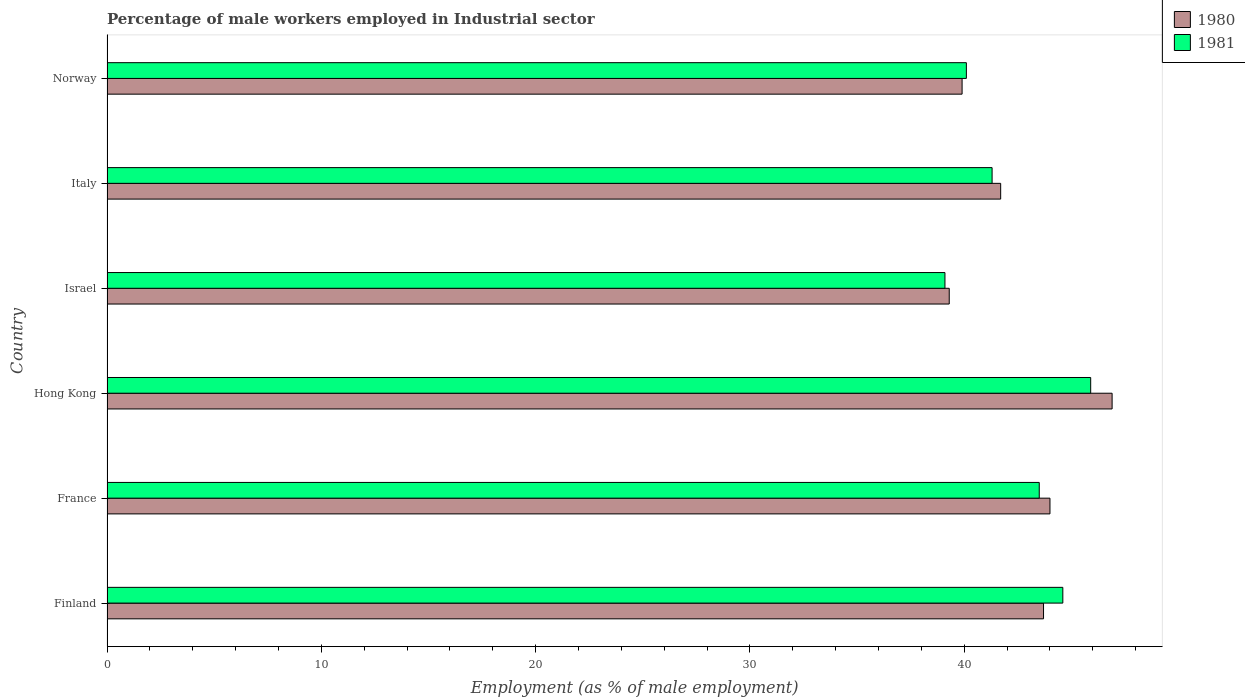How many groups of bars are there?
Keep it short and to the point. 6. Are the number of bars per tick equal to the number of legend labels?
Your answer should be compact. Yes. Are the number of bars on each tick of the Y-axis equal?
Keep it short and to the point. Yes. How many bars are there on the 1st tick from the top?
Provide a short and direct response. 2. How many bars are there on the 5th tick from the bottom?
Offer a terse response. 2. What is the label of the 4th group of bars from the top?
Keep it short and to the point. Hong Kong. What is the percentage of male workers employed in Industrial sector in 1980 in Hong Kong?
Your response must be concise. 46.9. Across all countries, what is the maximum percentage of male workers employed in Industrial sector in 1981?
Offer a terse response. 45.9. Across all countries, what is the minimum percentage of male workers employed in Industrial sector in 1980?
Offer a terse response. 39.3. In which country was the percentage of male workers employed in Industrial sector in 1980 maximum?
Offer a terse response. Hong Kong. What is the total percentage of male workers employed in Industrial sector in 1981 in the graph?
Provide a short and direct response. 254.5. What is the difference between the percentage of male workers employed in Industrial sector in 1980 in Finland and that in France?
Provide a short and direct response. -0.3. What is the difference between the percentage of male workers employed in Industrial sector in 1980 in Finland and the percentage of male workers employed in Industrial sector in 1981 in Norway?
Make the answer very short. 3.6. What is the average percentage of male workers employed in Industrial sector in 1980 per country?
Ensure brevity in your answer.  42.58. What is the difference between the percentage of male workers employed in Industrial sector in 1981 and percentage of male workers employed in Industrial sector in 1980 in Norway?
Provide a short and direct response. 0.2. What is the ratio of the percentage of male workers employed in Industrial sector in 1980 in Hong Kong to that in Norway?
Offer a very short reply. 1.18. What is the difference between the highest and the second highest percentage of male workers employed in Industrial sector in 1981?
Provide a short and direct response. 1.3. What is the difference between the highest and the lowest percentage of male workers employed in Industrial sector in 1980?
Ensure brevity in your answer.  7.6. In how many countries, is the percentage of male workers employed in Industrial sector in 1980 greater than the average percentage of male workers employed in Industrial sector in 1980 taken over all countries?
Provide a short and direct response. 3. Is the sum of the percentage of male workers employed in Industrial sector in 1981 in France and Hong Kong greater than the maximum percentage of male workers employed in Industrial sector in 1980 across all countries?
Make the answer very short. Yes. What does the 1st bar from the top in Norway represents?
Provide a short and direct response. 1981. How many bars are there?
Ensure brevity in your answer.  12. How many countries are there in the graph?
Make the answer very short. 6. Are the values on the major ticks of X-axis written in scientific E-notation?
Give a very brief answer. No. Does the graph contain any zero values?
Provide a short and direct response. No. Where does the legend appear in the graph?
Give a very brief answer. Top right. What is the title of the graph?
Offer a terse response. Percentage of male workers employed in Industrial sector. What is the label or title of the X-axis?
Your response must be concise. Employment (as % of male employment). What is the Employment (as % of male employment) in 1980 in Finland?
Offer a terse response. 43.7. What is the Employment (as % of male employment) in 1981 in Finland?
Offer a terse response. 44.6. What is the Employment (as % of male employment) of 1981 in France?
Ensure brevity in your answer.  43.5. What is the Employment (as % of male employment) in 1980 in Hong Kong?
Offer a very short reply. 46.9. What is the Employment (as % of male employment) of 1981 in Hong Kong?
Make the answer very short. 45.9. What is the Employment (as % of male employment) of 1980 in Israel?
Keep it short and to the point. 39.3. What is the Employment (as % of male employment) in 1981 in Israel?
Provide a succinct answer. 39.1. What is the Employment (as % of male employment) in 1980 in Italy?
Ensure brevity in your answer.  41.7. What is the Employment (as % of male employment) in 1981 in Italy?
Keep it short and to the point. 41.3. What is the Employment (as % of male employment) in 1980 in Norway?
Your answer should be compact. 39.9. What is the Employment (as % of male employment) in 1981 in Norway?
Make the answer very short. 40.1. Across all countries, what is the maximum Employment (as % of male employment) in 1980?
Keep it short and to the point. 46.9. Across all countries, what is the maximum Employment (as % of male employment) in 1981?
Offer a very short reply. 45.9. Across all countries, what is the minimum Employment (as % of male employment) in 1980?
Ensure brevity in your answer.  39.3. Across all countries, what is the minimum Employment (as % of male employment) in 1981?
Your response must be concise. 39.1. What is the total Employment (as % of male employment) of 1980 in the graph?
Your response must be concise. 255.5. What is the total Employment (as % of male employment) in 1981 in the graph?
Keep it short and to the point. 254.5. What is the difference between the Employment (as % of male employment) in 1980 in Finland and that in France?
Keep it short and to the point. -0.3. What is the difference between the Employment (as % of male employment) of 1981 in Finland and that in France?
Keep it short and to the point. 1.1. What is the difference between the Employment (as % of male employment) in 1980 in Finland and that in Hong Kong?
Make the answer very short. -3.2. What is the difference between the Employment (as % of male employment) of 1980 in Finland and that in Norway?
Your response must be concise. 3.8. What is the difference between the Employment (as % of male employment) in 1981 in France and that in Hong Kong?
Provide a short and direct response. -2.4. What is the difference between the Employment (as % of male employment) of 1981 in France and that in Israel?
Your response must be concise. 4.4. What is the difference between the Employment (as % of male employment) of 1980 in France and that in Norway?
Make the answer very short. 4.1. What is the difference between the Employment (as % of male employment) of 1981 in France and that in Norway?
Give a very brief answer. 3.4. What is the difference between the Employment (as % of male employment) in 1980 in Hong Kong and that in Israel?
Make the answer very short. 7.6. What is the difference between the Employment (as % of male employment) of 1981 in Hong Kong and that in Israel?
Your answer should be very brief. 6.8. What is the difference between the Employment (as % of male employment) in 1981 in Hong Kong and that in Italy?
Keep it short and to the point. 4.6. What is the difference between the Employment (as % of male employment) in 1980 in Israel and that in Italy?
Offer a very short reply. -2.4. What is the difference between the Employment (as % of male employment) of 1981 in Israel and that in Italy?
Offer a very short reply. -2.2. What is the difference between the Employment (as % of male employment) of 1981 in Israel and that in Norway?
Make the answer very short. -1. What is the difference between the Employment (as % of male employment) of 1980 in Italy and that in Norway?
Provide a succinct answer. 1.8. What is the difference between the Employment (as % of male employment) in 1980 in Finland and the Employment (as % of male employment) in 1981 in France?
Provide a succinct answer. 0.2. What is the difference between the Employment (as % of male employment) of 1980 in Finland and the Employment (as % of male employment) of 1981 in Hong Kong?
Make the answer very short. -2.2. What is the difference between the Employment (as % of male employment) of 1980 in Finland and the Employment (as % of male employment) of 1981 in Israel?
Make the answer very short. 4.6. What is the difference between the Employment (as % of male employment) in 1980 in France and the Employment (as % of male employment) in 1981 in Hong Kong?
Make the answer very short. -1.9. What is the difference between the Employment (as % of male employment) of 1980 in France and the Employment (as % of male employment) of 1981 in Israel?
Make the answer very short. 4.9. What is the difference between the Employment (as % of male employment) in 1980 in France and the Employment (as % of male employment) in 1981 in Italy?
Offer a very short reply. 2.7. What is the difference between the Employment (as % of male employment) of 1980 in Hong Kong and the Employment (as % of male employment) of 1981 in Israel?
Your response must be concise. 7.8. What is the difference between the Employment (as % of male employment) in 1980 in Hong Kong and the Employment (as % of male employment) in 1981 in Italy?
Offer a terse response. 5.6. What is the difference between the Employment (as % of male employment) in 1980 in Hong Kong and the Employment (as % of male employment) in 1981 in Norway?
Keep it short and to the point. 6.8. What is the average Employment (as % of male employment) of 1980 per country?
Offer a very short reply. 42.58. What is the average Employment (as % of male employment) of 1981 per country?
Provide a succinct answer. 42.42. What is the difference between the Employment (as % of male employment) in 1980 and Employment (as % of male employment) in 1981 in Finland?
Provide a short and direct response. -0.9. What is the difference between the Employment (as % of male employment) of 1980 and Employment (as % of male employment) of 1981 in Israel?
Make the answer very short. 0.2. What is the ratio of the Employment (as % of male employment) in 1981 in Finland to that in France?
Your answer should be compact. 1.03. What is the ratio of the Employment (as % of male employment) of 1980 in Finland to that in Hong Kong?
Your answer should be compact. 0.93. What is the ratio of the Employment (as % of male employment) in 1981 in Finland to that in Hong Kong?
Offer a very short reply. 0.97. What is the ratio of the Employment (as % of male employment) in 1980 in Finland to that in Israel?
Make the answer very short. 1.11. What is the ratio of the Employment (as % of male employment) of 1981 in Finland to that in Israel?
Provide a succinct answer. 1.14. What is the ratio of the Employment (as % of male employment) in 1980 in Finland to that in Italy?
Ensure brevity in your answer.  1.05. What is the ratio of the Employment (as % of male employment) of 1981 in Finland to that in Italy?
Keep it short and to the point. 1.08. What is the ratio of the Employment (as % of male employment) in 1980 in Finland to that in Norway?
Make the answer very short. 1.1. What is the ratio of the Employment (as % of male employment) in 1981 in Finland to that in Norway?
Your response must be concise. 1.11. What is the ratio of the Employment (as % of male employment) in 1980 in France to that in Hong Kong?
Offer a terse response. 0.94. What is the ratio of the Employment (as % of male employment) in 1981 in France to that in Hong Kong?
Provide a succinct answer. 0.95. What is the ratio of the Employment (as % of male employment) of 1980 in France to that in Israel?
Offer a very short reply. 1.12. What is the ratio of the Employment (as % of male employment) in 1981 in France to that in Israel?
Offer a terse response. 1.11. What is the ratio of the Employment (as % of male employment) in 1980 in France to that in Italy?
Your response must be concise. 1.06. What is the ratio of the Employment (as % of male employment) in 1981 in France to that in Italy?
Offer a very short reply. 1.05. What is the ratio of the Employment (as % of male employment) in 1980 in France to that in Norway?
Offer a very short reply. 1.1. What is the ratio of the Employment (as % of male employment) of 1981 in France to that in Norway?
Your response must be concise. 1.08. What is the ratio of the Employment (as % of male employment) in 1980 in Hong Kong to that in Israel?
Ensure brevity in your answer.  1.19. What is the ratio of the Employment (as % of male employment) in 1981 in Hong Kong to that in Israel?
Make the answer very short. 1.17. What is the ratio of the Employment (as % of male employment) of 1980 in Hong Kong to that in Italy?
Provide a succinct answer. 1.12. What is the ratio of the Employment (as % of male employment) of 1981 in Hong Kong to that in Italy?
Ensure brevity in your answer.  1.11. What is the ratio of the Employment (as % of male employment) of 1980 in Hong Kong to that in Norway?
Give a very brief answer. 1.18. What is the ratio of the Employment (as % of male employment) of 1981 in Hong Kong to that in Norway?
Provide a short and direct response. 1.14. What is the ratio of the Employment (as % of male employment) of 1980 in Israel to that in Italy?
Your response must be concise. 0.94. What is the ratio of the Employment (as % of male employment) of 1981 in Israel to that in Italy?
Offer a terse response. 0.95. What is the ratio of the Employment (as % of male employment) of 1981 in Israel to that in Norway?
Offer a very short reply. 0.98. What is the ratio of the Employment (as % of male employment) of 1980 in Italy to that in Norway?
Make the answer very short. 1.05. What is the ratio of the Employment (as % of male employment) in 1981 in Italy to that in Norway?
Offer a very short reply. 1.03. What is the difference between the highest and the second highest Employment (as % of male employment) in 1980?
Your answer should be very brief. 2.9. What is the difference between the highest and the lowest Employment (as % of male employment) of 1980?
Your answer should be compact. 7.6. What is the difference between the highest and the lowest Employment (as % of male employment) of 1981?
Your answer should be very brief. 6.8. 